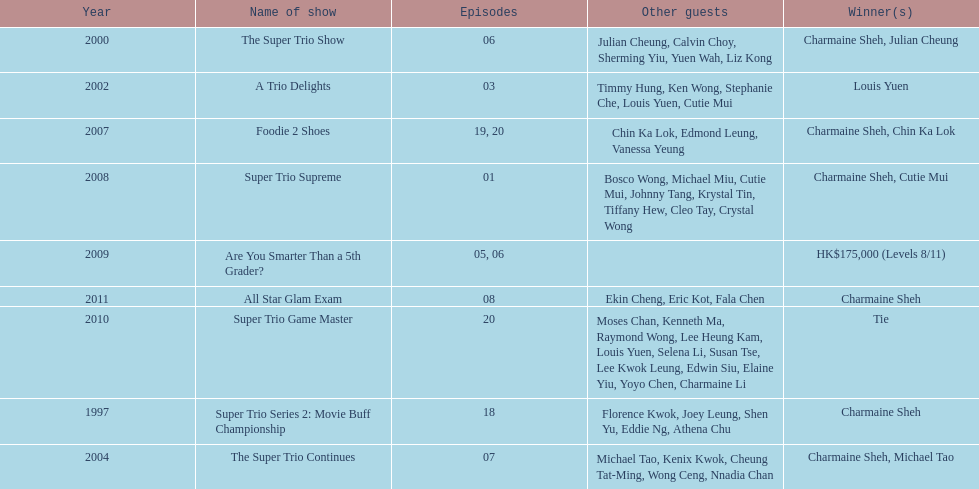How many episodes was charmaine sheh on in the variety show super trio 2: movie buff champions 18. 